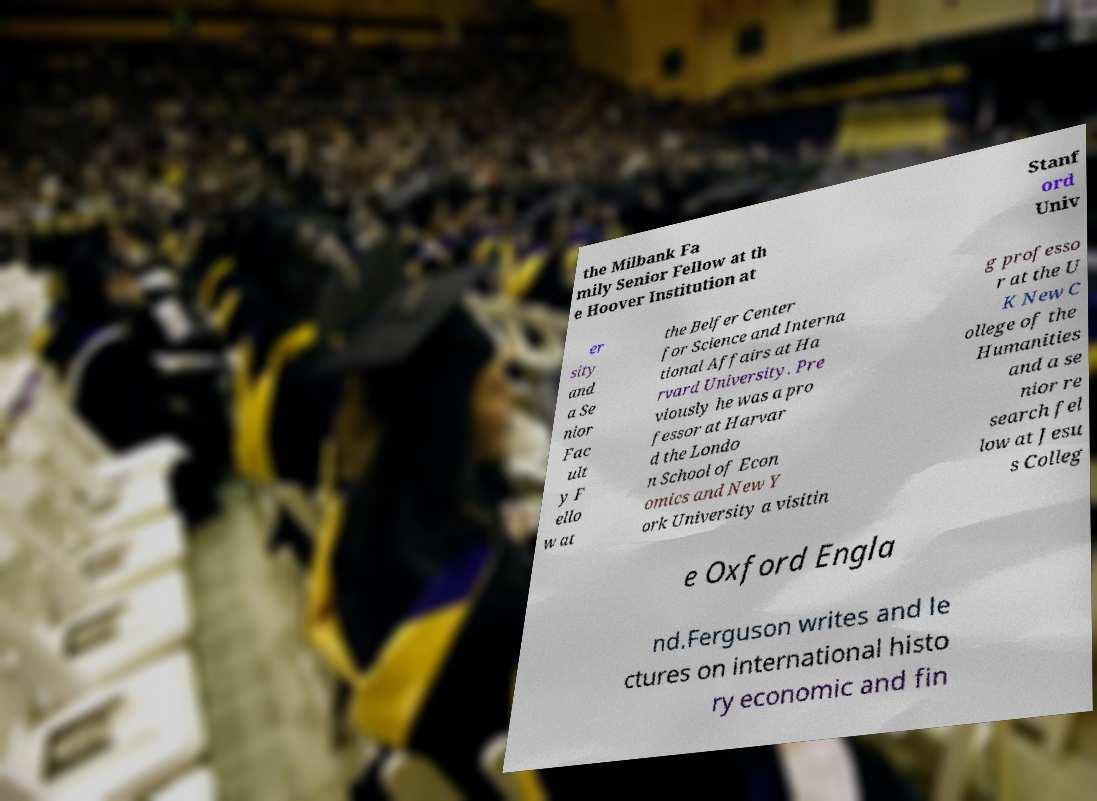There's text embedded in this image that I need extracted. Can you transcribe it verbatim? the Milbank Fa mily Senior Fellow at th e Hoover Institution at Stanf ord Univ er sity and a Se nior Fac ult y F ello w at the Belfer Center for Science and Interna tional Affairs at Ha rvard University. Pre viously he was a pro fessor at Harvar d the Londo n School of Econ omics and New Y ork University a visitin g professo r at the U K New C ollege of the Humanities and a se nior re search fel low at Jesu s Colleg e Oxford Engla nd.Ferguson writes and le ctures on international histo ry economic and fin 